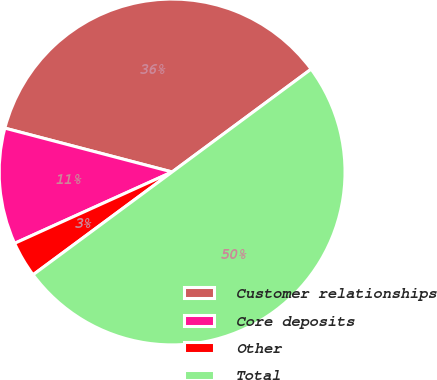<chart> <loc_0><loc_0><loc_500><loc_500><pie_chart><fcel>Customer relationships<fcel>Core deposits<fcel>Other<fcel>Total<nl><fcel>35.78%<fcel>10.85%<fcel>3.36%<fcel>50.0%<nl></chart> 